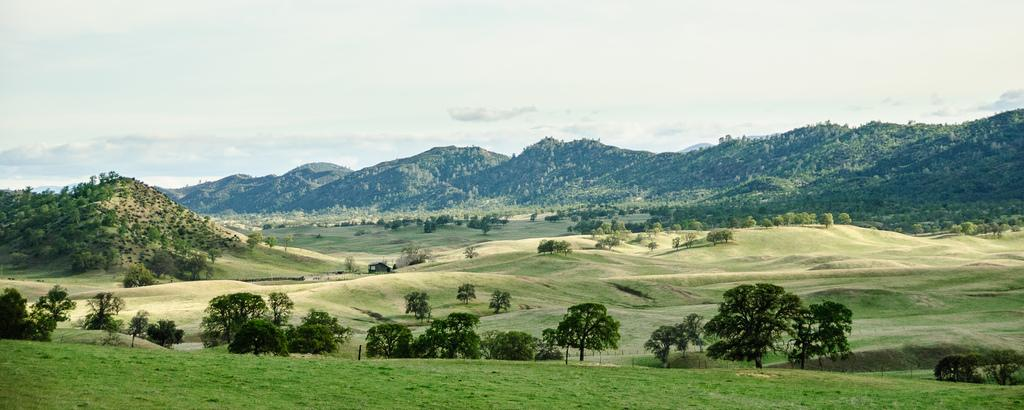What type of vegetation can be seen in the image? There is grass in the image. What other natural elements are present in the image? There are trees and mountains in the image. What can be seen in the background of the image? The sky is visible in the background of the image. What type of lettuce is growing on the mountains in the image? There is no lettuce present in the image; it features grass, trees, and mountains. What paper products can be seen in the image? There are no paper products visible in the image. 